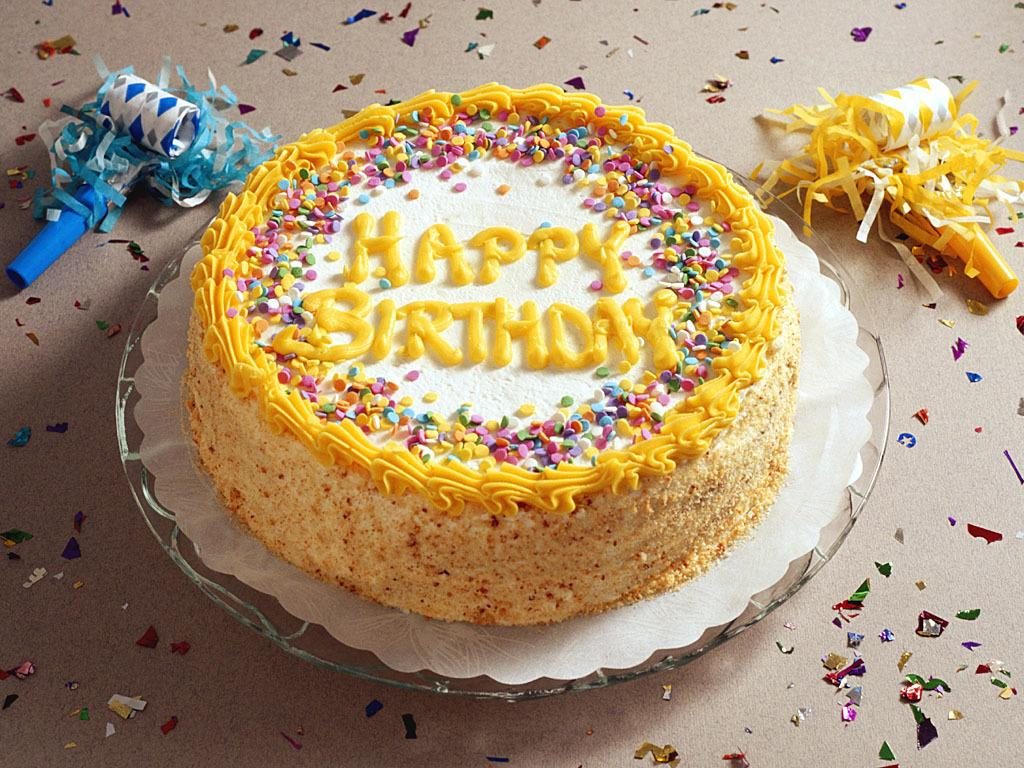What is the main subject in the middle of the image? There is a cake in the middle of the image. What can be seen on the cake? The cake has text on it. What objects are on either side of the image? There are birthday whistle toys on either side of the image. What type of business is being conducted in the image? There is no indication of any business being conducted in the image; it primarily features a cake with text and birthday whistle toys. 